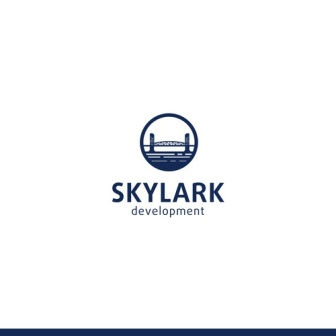Imagine this logo as part of a futuristic city. What would the city look like and what technological advancements might it showcase? Picture a futuristic city where cutting-edge technology seamlessly integrates with everyday life. The skyline is dominated by glistening skyscrapers equipped with green roofs and vertical gardens. Transparent glass domes house entire ecosystems, creating self-sufficient urban forests. Autonomous vehicles glide silently through the air and on the ground, reducing congestion and pollution. Smart infrastructure monitors and optimizes energy consumption across the city, while holographic displays provide real-time information to residents. The bridge in the logo, now realized, connects floating islands of the city, creating a vibrant network of thriving urban hubs, each a marvel of modern engineering and sustainable design.  What's the story behind the name 'Skylark Development'? In the early days of the company's inception, the founders were inspired by the skylarks—birds known for their melodic songs and high-altitude flights. They envisioned their urban development projects as soaring high above the ordinary, aiming to create environments that are not only functional but also uplifting and aesthetically pleasing. The name 'Skylark Development' embodies this vision of reaching new heights and transforming cityscapes into harmonious and innovative living spaces. 